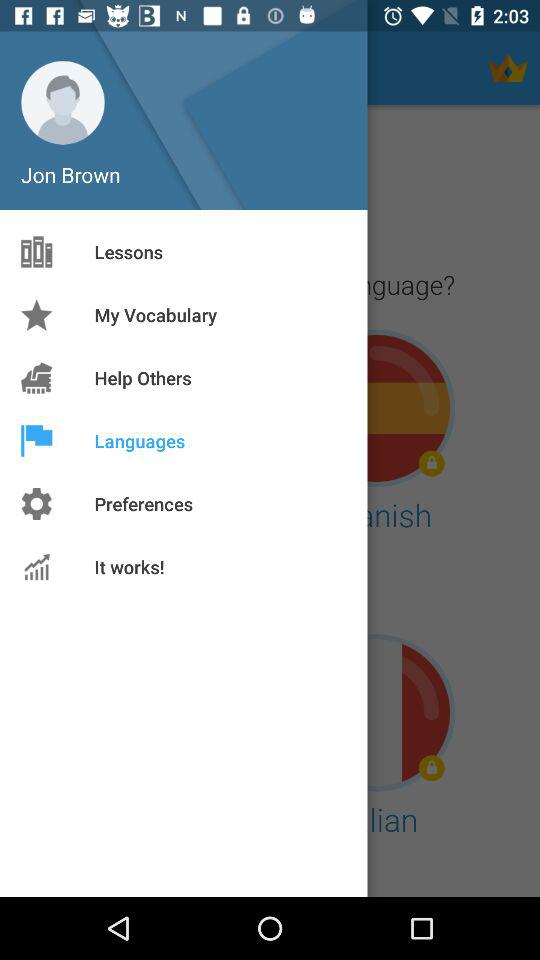What is the name of the user? The name of the user is Jon Brown. 